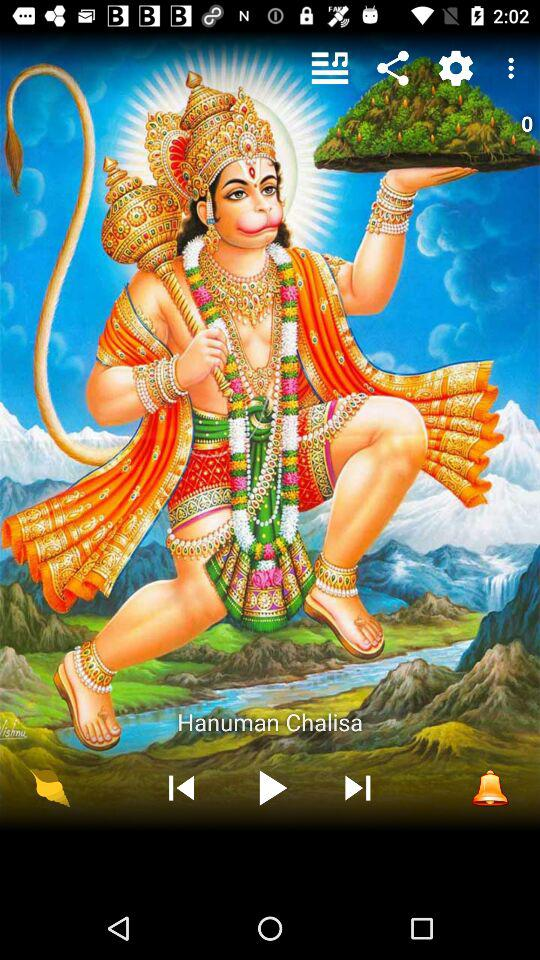Which song was last played? The last played song was "Hanuman Chalisa". 